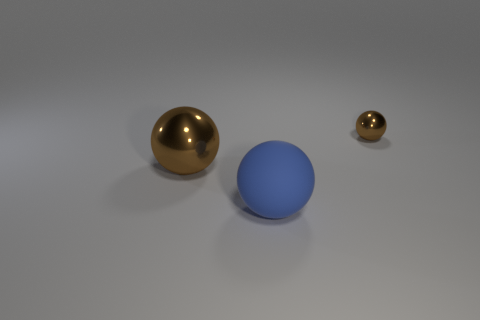If this image had a theme, what would you say it is? The theme of this image might relate to minimalism and contrast. With only a few objects presented against a neutral background, it showcases simplicity, while the contrast is highlighted by the different colors and sizes of the spheres. 